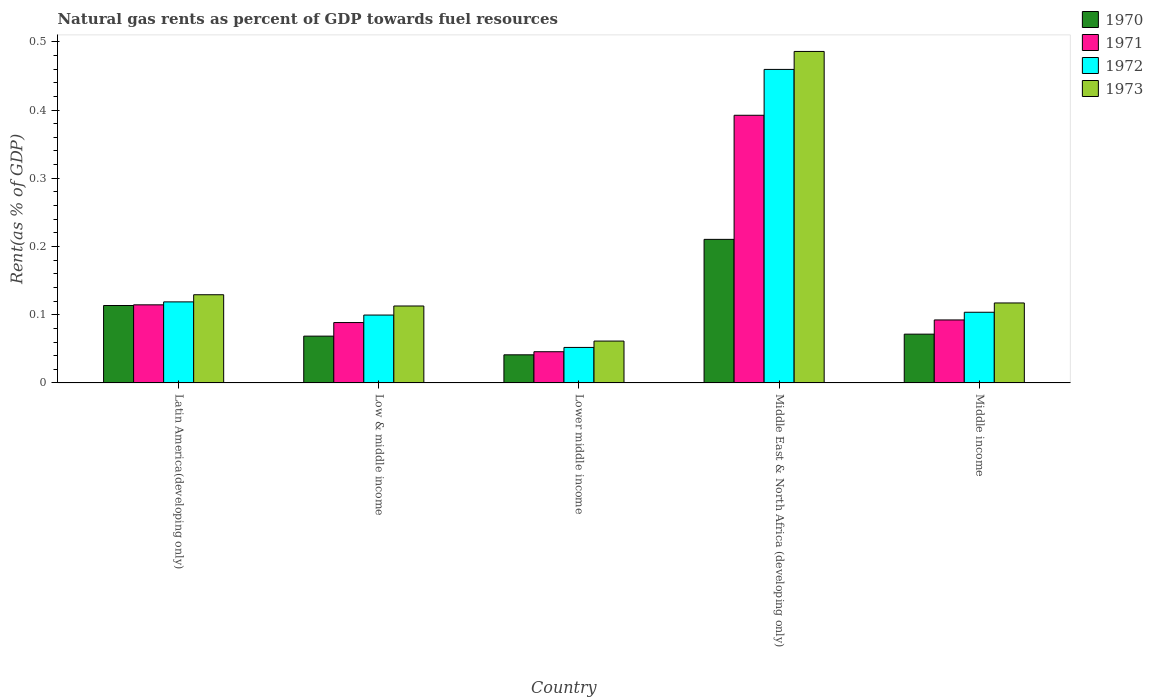Are the number of bars per tick equal to the number of legend labels?
Provide a short and direct response. Yes. How many bars are there on the 2nd tick from the left?
Offer a very short reply. 4. How many bars are there on the 5th tick from the right?
Provide a short and direct response. 4. What is the label of the 5th group of bars from the left?
Provide a short and direct response. Middle income. What is the matural gas rent in 1971 in Low & middle income?
Make the answer very short. 0.09. Across all countries, what is the maximum matural gas rent in 1972?
Offer a very short reply. 0.46. Across all countries, what is the minimum matural gas rent in 1973?
Provide a short and direct response. 0.06. In which country was the matural gas rent in 1972 maximum?
Provide a succinct answer. Middle East & North Africa (developing only). In which country was the matural gas rent in 1970 minimum?
Offer a terse response. Lower middle income. What is the total matural gas rent in 1972 in the graph?
Give a very brief answer. 0.83. What is the difference between the matural gas rent in 1970 in Low & middle income and that in Middle East & North Africa (developing only)?
Make the answer very short. -0.14. What is the difference between the matural gas rent in 1970 in Latin America(developing only) and the matural gas rent in 1973 in Middle income?
Keep it short and to the point. -0. What is the average matural gas rent in 1970 per country?
Provide a succinct answer. 0.1. What is the difference between the matural gas rent of/in 1973 and matural gas rent of/in 1970 in Lower middle income?
Offer a very short reply. 0.02. In how many countries, is the matural gas rent in 1972 greater than 0.1 %?
Provide a succinct answer. 3. What is the ratio of the matural gas rent in 1970 in Low & middle income to that in Middle East & North Africa (developing only)?
Offer a very short reply. 0.33. What is the difference between the highest and the second highest matural gas rent in 1973?
Your response must be concise. 0.37. What is the difference between the highest and the lowest matural gas rent in 1971?
Your response must be concise. 0.35. In how many countries, is the matural gas rent in 1970 greater than the average matural gas rent in 1970 taken over all countries?
Make the answer very short. 2. Is the sum of the matural gas rent in 1973 in Low & middle income and Middle income greater than the maximum matural gas rent in 1972 across all countries?
Offer a terse response. No. Is it the case that in every country, the sum of the matural gas rent in 1970 and matural gas rent in 1972 is greater than the sum of matural gas rent in 1973 and matural gas rent in 1971?
Your response must be concise. No. What does the 4th bar from the left in Latin America(developing only) represents?
Your answer should be compact. 1973. Is it the case that in every country, the sum of the matural gas rent in 1970 and matural gas rent in 1971 is greater than the matural gas rent in 1972?
Provide a succinct answer. Yes. How many bars are there?
Ensure brevity in your answer.  20. Are the values on the major ticks of Y-axis written in scientific E-notation?
Give a very brief answer. No. Does the graph contain any zero values?
Your response must be concise. No. Does the graph contain grids?
Your answer should be very brief. No. Where does the legend appear in the graph?
Offer a terse response. Top right. How are the legend labels stacked?
Offer a very short reply. Vertical. What is the title of the graph?
Ensure brevity in your answer.  Natural gas rents as percent of GDP towards fuel resources. Does "2004" appear as one of the legend labels in the graph?
Provide a short and direct response. No. What is the label or title of the Y-axis?
Provide a succinct answer. Rent(as % of GDP). What is the Rent(as % of GDP) of 1970 in Latin America(developing only)?
Your answer should be very brief. 0.11. What is the Rent(as % of GDP) in 1971 in Latin America(developing only)?
Offer a very short reply. 0.11. What is the Rent(as % of GDP) in 1972 in Latin America(developing only)?
Offer a terse response. 0.12. What is the Rent(as % of GDP) in 1973 in Latin America(developing only)?
Your answer should be very brief. 0.13. What is the Rent(as % of GDP) in 1970 in Low & middle income?
Your answer should be compact. 0.07. What is the Rent(as % of GDP) of 1971 in Low & middle income?
Your answer should be very brief. 0.09. What is the Rent(as % of GDP) of 1972 in Low & middle income?
Offer a very short reply. 0.1. What is the Rent(as % of GDP) in 1973 in Low & middle income?
Provide a short and direct response. 0.11. What is the Rent(as % of GDP) of 1970 in Lower middle income?
Keep it short and to the point. 0.04. What is the Rent(as % of GDP) in 1971 in Lower middle income?
Offer a terse response. 0.05. What is the Rent(as % of GDP) in 1972 in Lower middle income?
Your answer should be compact. 0.05. What is the Rent(as % of GDP) of 1973 in Lower middle income?
Ensure brevity in your answer.  0.06. What is the Rent(as % of GDP) of 1970 in Middle East & North Africa (developing only)?
Make the answer very short. 0.21. What is the Rent(as % of GDP) of 1971 in Middle East & North Africa (developing only)?
Ensure brevity in your answer.  0.39. What is the Rent(as % of GDP) in 1972 in Middle East & North Africa (developing only)?
Your answer should be compact. 0.46. What is the Rent(as % of GDP) in 1973 in Middle East & North Africa (developing only)?
Keep it short and to the point. 0.49. What is the Rent(as % of GDP) in 1970 in Middle income?
Offer a very short reply. 0.07. What is the Rent(as % of GDP) in 1971 in Middle income?
Your response must be concise. 0.09. What is the Rent(as % of GDP) in 1972 in Middle income?
Your response must be concise. 0.1. What is the Rent(as % of GDP) in 1973 in Middle income?
Ensure brevity in your answer.  0.12. Across all countries, what is the maximum Rent(as % of GDP) of 1970?
Make the answer very short. 0.21. Across all countries, what is the maximum Rent(as % of GDP) of 1971?
Provide a short and direct response. 0.39. Across all countries, what is the maximum Rent(as % of GDP) of 1972?
Your answer should be very brief. 0.46. Across all countries, what is the maximum Rent(as % of GDP) in 1973?
Provide a succinct answer. 0.49. Across all countries, what is the minimum Rent(as % of GDP) in 1970?
Provide a succinct answer. 0.04. Across all countries, what is the minimum Rent(as % of GDP) in 1971?
Provide a short and direct response. 0.05. Across all countries, what is the minimum Rent(as % of GDP) in 1972?
Keep it short and to the point. 0.05. Across all countries, what is the minimum Rent(as % of GDP) in 1973?
Give a very brief answer. 0.06. What is the total Rent(as % of GDP) in 1970 in the graph?
Your answer should be very brief. 0.51. What is the total Rent(as % of GDP) of 1971 in the graph?
Ensure brevity in your answer.  0.73. What is the total Rent(as % of GDP) in 1972 in the graph?
Offer a terse response. 0.83. What is the total Rent(as % of GDP) in 1973 in the graph?
Ensure brevity in your answer.  0.91. What is the difference between the Rent(as % of GDP) of 1970 in Latin America(developing only) and that in Low & middle income?
Your answer should be very brief. 0.04. What is the difference between the Rent(as % of GDP) in 1971 in Latin America(developing only) and that in Low & middle income?
Your answer should be very brief. 0.03. What is the difference between the Rent(as % of GDP) of 1972 in Latin America(developing only) and that in Low & middle income?
Keep it short and to the point. 0.02. What is the difference between the Rent(as % of GDP) of 1973 in Latin America(developing only) and that in Low & middle income?
Provide a succinct answer. 0.02. What is the difference between the Rent(as % of GDP) in 1970 in Latin America(developing only) and that in Lower middle income?
Your response must be concise. 0.07. What is the difference between the Rent(as % of GDP) in 1971 in Latin America(developing only) and that in Lower middle income?
Make the answer very short. 0.07. What is the difference between the Rent(as % of GDP) of 1972 in Latin America(developing only) and that in Lower middle income?
Provide a succinct answer. 0.07. What is the difference between the Rent(as % of GDP) in 1973 in Latin America(developing only) and that in Lower middle income?
Give a very brief answer. 0.07. What is the difference between the Rent(as % of GDP) of 1970 in Latin America(developing only) and that in Middle East & North Africa (developing only)?
Your answer should be very brief. -0.1. What is the difference between the Rent(as % of GDP) of 1971 in Latin America(developing only) and that in Middle East & North Africa (developing only)?
Your answer should be compact. -0.28. What is the difference between the Rent(as % of GDP) of 1972 in Latin America(developing only) and that in Middle East & North Africa (developing only)?
Keep it short and to the point. -0.34. What is the difference between the Rent(as % of GDP) in 1973 in Latin America(developing only) and that in Middle East & North Africa (developing only)?
Give a very brief answer. -0.36. What is the difference between the Rent(as % of GDP) of 1970 in Latin America(developing only) and that in Middle income?
Give a very brief answer. 0.04. What is the difference between the Rent(as % of GDP) in 1971 in Latin America(developing only) and that in Middle income?
Give a very brief answer. 0.02. What is the difference between the Rent(as % of GDP) in 1972 in Latin America(developing only) and that in Middle income?
Your response must be concise. 0.02. What is the difference between the Rent(as % of GDP) of 1973 in Latin America(developing only) and that in Middle income?
Offer a very short reply. 0.01. What is the difference between the Rent(as % of GDP) in 1970 in Low & middle income and that in Lower middle income?
Offer a very short reply. 0.03. What is the difference between the Rent(as % of GDP) in 1971 in Low & middle income and that in Lower middle income?
Give a very brief answer. 0.04. What is the difference between the Rent(as % of GDP) of 1972 in Low & middle income and that in Lower middle income?
Provide a succinct answer. 0.05. What is the difference between the Rent(as % of GDP) of 1973 in Low & middle income and that in Lower middle income?
Your answer should be compact. 0.05. What is the difference between the Rent(as % of GDP) of 1970 in Low & middle income and that in Middle East & North Africa (developing only)?
Provide a short and direct response. -0.14. What is the difference between the Rent(as % of GDP) of 1971 in Low & middle income and that in Middle East & North Africa (developing only)?
Ensure brevity in your answer.  -0.3. What is the difference between the Rent(as % of GDP) in 1972 in Low & middle income and that in Middle East & North Africa (developing only)?
Your answer should be compact. -0.36. What is the difference between the Rent(as % of GDP) in 1973 in Low & middle income and that in Middle East & North Africa (developing only)?
Ensure brevity in your answer.  -0.37. What is the difference between the Rent(as % of GDP) in 1970 in Low & middle income and that in Middle income?
Keep it short and to the point. -0. What is the difference between the Rent(as % of GDP) of 1971 in Low & middle income and that in Middle income?
Make the answer very short. -0. What is the difference between the Rent(as % of GDP) in 1972 in Low & middle income and that in Middle income?
Provide a succinct answer. -0. What is the difference between the Rent(as % of GDP) of 1973 in Low & middle income and that in Middle income?
Offer a very short reply. -0. What is the difference between the Rent(as % of GDP) of 1970 in Lower middle income and that in Middle East & North Africa (developing only)?
Ensure brevity in your answer.  -0.17. What is the difference between the Rent(as % of GDP) of 1971 in Lower middle income and that in Middle East & North Africa (developing only)?
Your answer should be very brief. -0.35. What is the difference between the Rent(as % of GDP) of 1972 in Lower middle income and that in Middle East & North Africa (developing only)?
Make the answer very short. -0.41. What is the difference between the Rent(as % of GDP) in 1973 in Lower middle income and that in Middle East & North Africa (developing only)?
Provide a short and direct response. -0.42. What is the difference between the Rent(as % of GDP) of 1970 in Lower middle income and that in Middle income?
Your answer should be very brief. -0.03. What is the difference between the Rent(as % of GDP) of 1971 in Lower middle income and that in Middle income?
Your answer should be very brief. -0.05. What is the difference between the Rent(as % of GDP) in 1972 in Lower middle income and that in Middle income?
Give a very brief answer. -0.05. What is the difference between the Rent(as % of GDP) of 1973 in Lower middle income and that in Middle income?
Offer a very short reply. -0.06. What is the difference between the Rent(as % of GDP) of 1970 in Middle East & North Africa (developing only) and that in Middle income?
Your answer should be compact. 0.14. What is the difference between the Rent(as % of GDP) in 1972 in Middle East & North Africa (developing only) and that in Middle income?
Keep it short and to the point. 0.36. What is the difference between the Rent(as % of GDP) of 1973 in Middle East & North Africa (developing only) and that in Middle income?
Keep it short and to the point. 0.37. What is the difference between the Rent(as % of GDP) in 1970 in Latin America(developing only) and the Rent(as % of GDP) in 1971 in Low & middle income?
Provide a succinct answer. 0.03. What is the difference between the Rent(as % of GDP) of 1970 in Latin America(developing only) and the Rent(as % of GDP) of 1972 in Low & middle income?
Your response must be concise. 0.01. What is the difference between the Rent(as % of GDP) of 1970 in Latin America(developing only) and the Rent(as % of GDP) of 1973 in Low & middle income?
Give a very brief answer. 0. What is the difference between the Rent(as % of GDP) in 1971 in Latin America(developing only) and the Rent(as % of GDP) in 1972 in Low & middle income?
Give a very brief answer. 0.01. What is the difference between the Rent(as % of GDP) in 1971 in Latin America(developing only) and the Rent(as % of GDP) in 1973 in Low & middle income?
Keep it short and to the point. 0. What is the difference between the Rent(as % of GDP) in 1972 in Latin America(developing only) and the Rent(as % of GDP) in 1973 in Low & middle income?
Your answer should be compact. 0.01. What is the difference between the Rent(as % of GDP) in 1970 in Latin America(developing only) and the Rent(as % of GDP) in 1971 in Lower middle income?
Give a very brief answer. 0.07. What is the difference between the Rent(as % of GDP) in 1970 in Latin America(developing only) and the Rent(as % of GDP) in 1972 in Lower middle income?
Offer a very short reply. 0.06. What is the difference between the Rent(as % of GDP) in 1970 in Latin America(developing only) and the Rent(as % of GDP) in 1973 in Lower middle income?
Your answer should be very brief. 0.05. What is the difference between the Rent(as % of GDP) in 1971 in Latin America(developing only) and the Rent(as % of GDP) in 1972 in Lower middle income?
Make the answer very short. 0.06. What is the difference between the Rent(as % of GDP) of 1971 in Latin America(developing only) and the Rent(as % of GDP) of 1973 in Lower middle income?
Your response must be concise. 0.05. What is the difference between the Rent(as % of GDP) of 1972 in Latin America(developing only) and the Rent(as % of GDP) of 1973 in Lower middle income?
Provide a short and direct response. 0.06. What is the difference between the Rent(as % of GDP) of 1970 in Latin America(developing only) and the Rent(as % of GDP) of 1971 in Middle East & North Africa (developing only)?
Your answer should be compact. -0.28. What is the difference between the Rent(as % of GDP) in 1970 in Latin America(developing only) and the Rent(as % of GDP) in 1972 in Middle East & North Africa (developing only)?
Keep it short and to the point. -0.35. What is the difference between the Rent(as % of GDP) of 1970 in Latin America(developing only) and the Rent(as % of GDP) of 1973 in Middle East & North Africa (developing only)?
Provide a succinct answer. -0.37. What is the difference between the Rent(as % of GDP) in 1971 in Latin America(developing only) and the Rent(as % of GDP) in 1972 in Middle East & North Africa (developing only)?
Offer a terse response. -0.35. What is the difference between the Rent(as % of GDP) of 1971 in Latin America(developing only) and the Rent(as % of GDP) of 1973 in Middle East & North Africa (developing only)?
Keep it short and to the point. -0.37. What is the difference between the Rent(as % of GDP) of 1972 in Latin America(developing only) and the Rent(as % of GDP) of 1973 in Middle East & North Africa (developing only)?
Provide a succinct answer. -0.37. What is the difference between the Rent(as % of GDP) of 1970 in Latin America(developing only) and the Rent(as % of GDP) of 1971 in Middle income?
Your response must be concise. 0.02. What is the difference between the Rent(as % of GDP) in 1970 in Latin America(developing only) and the Rent(as % of GDP) in 1972 in Middle income?
Your answer should be very brief. 0.01. What is the difference between the Rent(as % of GDP) in 1970 in Latin America(developing only) and the Rent(as % of GDP) in 1973 in Middle income?
Your answer should be compact. -0. What is the difference between the Rent(as % of GDP) of 1971 in Latin America(developing only) and the Rent(as % of GDP) of 1972 in Middle income?
Keep it short and to the point. 0.01. What is the difference between the Rent(as % of GDP) of 1971 in Latin America(developing only) and the Rent(as % of GDP) of 1973 in Middle income?
Ensure brevity in your answer.  -0. What is the difference between the Rent(as % of GDP) of 1972 in Latin America(developing only) and the Rent(as % of GDP) of 1973 in Middle income?
Give a very brief answer. 0. What is the difference between the Rent(as % of GDP) of 1970 in Low & middle income and the Rent(as % of GDP) of 1971 in Lower middle income?
Ensure brevity in your answer.  0.02. What is the difference between the Rent(as % of GDP) of 1970 in Low & middle income and the Rent(as % of GDP) of 1972 in Lower middle income?
Provide a short and direct response. 0.02. What is the difference between the Rent(as % of GDP) of 1970 in Low & middle income and the Rent(as % of GDP) of 1973 in Lower middle income?
Ensure brevity in your answer.  0.01. What is the difference between the Rent(as % of GDP) in 1971 in Low & middle income and the Rent(as % of GDP) in 1972 in Lower middle income?
Your response must be concise. 0.04. What is the difference between the Rent(as % of GDP) of 1971 in Low & middle income and the Rent(as % of GDP) of 1973 in Lower middle income?
Give a very brief answer. 0.03. What is the difference between the Rent(as % of GDP) of 1972 in Low & middle income and the Rent(as % of GDP) of 1973 in Lower middle income?
Make the answer very short. 0.04. What is the difference between the Rent(as % of GDP) of 1970 in Low & middle income and the Rent(as % of GDP) of 1971 in Middle East & North Africa (developing only)?
Offer a terse response. -0.32. What is the difference between the Rent(as % of GDP) in 1970 in Low & middle income and the Rent(as % of GDP) in 1972 in Middle East & North Africa (developing only)?
Your answer should be very brief. -0.39. What is the difference between the Rent(as % of GDP) in 1970 in Low & middle income and the Rent(as % of GDP) in 1973 in Middle East & North Africa (developing only)?
Make the answer very short. -0.42. What is the difference between the Rent(as % of GDP) of 1971 in Low & middle income and the Rent(as % of GDP) of 1972 in Middle East & North Africa (developing only)?
Ensure brevity in your answer.  -0.37. What is the difference between the Rent(as % of GDP) in 1971 in Low & middle income and the Rent(as % of GDP) in 1973 in Middle East & North Africa (developing only)?
Offer a very short reply. -0.4. What is the difference between the Rent(as % of GDP) in 1972 in Low & middle income and the Rent(as % of GDP) in 1973 in Middle East & North Africa (developing only)?
Keep it short and to the point. -0.39. What is the difference between the Rent(as % of GDP) in 1970 in Low & middle income and the Rent(as % of GDP) in 1971 in Middle income?
Keep it short and to the point. -0.02. What is the difference between the Rent(as % of GDP) in 1970 in Low & middle income and the Rent(as % of GDP) in 1972 in Middle income?
Provide a short and direct response. -0.04. What is the difference between the Rent(as % of GDP) in 1970 in Low & middle income and the Rent(as % of GDP) in 1973 in Middle income?
Your response must be concise. -0.05. What is the difference between the Rent(as % of GDP) of 1971 in Low & middle income and the Rent(as % of GDP) of 1972 in Middle income?
Provide a short and direct response. -0.02. What is the difference between the Rent(as % of GDP) in 1971 in Low & middle income and the Rent(as % of GDP) in 1973 in Middle income?
Your response must be concise. -0.03. What is the difference between the Rent(as % of GDP) of 1972 in Low & middle income and the Rent(as % of GDP) of 1973 in Middle income?
Your response must be concise. -0.02. What is the difference between the Rent(as % of GDP) in 1970 in Lower middle income and the Rent(as % of GDP) in 1971 in Middle East & North Africa (developing only)?
Give a very brief answer. -0.35. What is the difference between the Rent(as % of GDP) in 1970 in Lower middle income and the Rent(as % of GDP) in 1972 in Middle East & North Africa (developing only)?
Make the answer very short. -0.42. What is the difference between the Rent(as % of GDP) in 1970 in Lower middle income and the Rent(as % of GDP) in 1973 in Middle East & North Africa (developing only)?
Your response must be concise. -0.44. What is the difference between the Rent(as % of GDP) in 1971 in Lower middle income and the Rent(as % of GDP) in 1972 in Middle East & North Africa (developing only)?
Your response must be concise. -0.41. What is the difference between the Rent(as % of GDP) in 1971 in Lower middle income and the Rent(as % of GDP) in 1973 in Middle East & North Africa (developing only)?
Make the answer very short. -0.44. What is the difference between the Rent(as % of GDP) of 1972 in Lower middle income and the Rent(as % of GDP) of 1973 in Middle East & North Africa (developing only)?
Ensure brevity in your answer.  -0.43. What is the difference between the Rent(as % of GDP) of 1970 in Lower middle income and the Rent(as % of GDP) of 1971 in Middle income?
Make the answer very short. -0.05. What is the difference between the Rent(as % of GDP) of 1970 in Lower middle income and the Rent(as % of GDP) of 1972 in Middle income?
Offer a very short reply. -0.06. What is the difference between the Rent(as % of GDP) of 1970 in Lower middle income and the Rent(as % of GDP) of 1973 in Middle income?
Provide a short and direct response. -0.08. What is the difference between the Rent(as % of GDP) in 1971 in Lower middle income and the Rent(as % of GDP) in 1972 in Middle income?
Offer a terse response. -0.06. What is the difference between the Rent(as % of GDP) of 1971 in Lower middle income and the Rent(as % of GDP) of 1973 in Middle income?
Offer a very short reply. -0.07. What is the difference between the Rent(as % of GDP) of 1972 in Lower middle income and the Rent(as % of GDP) of 1973 in Middle income?
Provide a short and direct response. -0.07. What is the difference between the Rent(as % of GDP) of 1970 in Middle East & North Africa (developing only) and the Rent(as % of GDP) of 1971 in Middle income?
Your answer should be very brief. 0.12. What is the difference between the Rent(as % of GDP) in 1970 in Middle East & North Africa (developing only) and the Rent(as % of GDP) in 1972 in Middle income?
Keep it short and to the point. 0.11. What is the difference between the Rent(as % of GDP) of 1970 in Middle East & North Africa (developing only) and the Rent(as % of GDP) of 1973 in Middle income?
Ensure brevity in your answer.  0.09. What is the difference between the Rent(as % of GDP) of 1971 in Middle East & North Africa (developing only) and the Rent(as % of GDP) of 1972 in Middle income?
Make the answer very short. 0.29. What is the difference between the Rent(as % of GDP) in 1971 in Middle East & North Africa (developing only) and the Rent(as % of GDP) in 1973 in Middle income?
Offer a terse response. 0.28. What is the difference between the Rent(as % of GDP) in 1972 in Middle East & North Africa (developing only) and the Rent(as % of GDP) in 1973 in Middle income?
Make the answer very short. 0.34. What is the average Rent(as % of GDP) of 1970 per country?
Keep it short and to the point. 0.1. What is the average Rent(as % of GDP) of 1971 per country?
Offer a very short reply. 0.15. What is the average Rent(as % of GDP) in 1972 per country?
Offer a terse response. 0.17. What is the average Rent(as % of GDP) of 1973 per country?
Provide a succinct answer. 0.18. What is the difference between the Rent(as % of GDP) in 1970 and Rent(as % of GDP) in 1971 in Latin America(developing only)?
Make the answer very short. -0. What is the difference between the Rent(as % of GDP) in 1970 and Rent(as % of GDP) in 1972 in Latin America(developing only)?
Your response must be concise. -0.01. What is the difference between the Rent(as % of GDP) in 1970 and Rent(as % of GDP) in 1973 in Latin America(developing only)?
Your response must be concise. -0.02. What is the difference between the Rent(as % of GDP) of 1971 and Rent(as % of GDP) of 1972 in Latin America(developing only)?
Keep it short and to the point. -0. What is the difference between the Rent(as % of GDP) of 1971 and Rent(as % of GDP) of 1973 in Latin America(developing only)?
Offer a very short reply. -0.01. What is the difference between the Rent(as % of GDP) in 1972 and Rent(as % of GDP) in 1973 in Latin America(developing only)?
Give a very brief answer. -0.01. What is the difference between the Rent(as % of GDP) in 1970 and Rent(as % of GDP) in 1971 in Low & middle income?
Ensure brevity in your answer.  -0.02. What is the difference between the Rent(as % of GDP) of 1970 and Rent(as % of GDP) of 1972 in Low & middle income?
Provide a succinct answer. -0.03. What is the difference between the Rent(as % of GDP) of 1970 and Rent(as % of GDP) of 1973 in Low & middle income?
Ensure brevity in your answer.  -0.04. What is the difference between the Rent(as % of GDP) in 1971 and Rent(as % of GDP) in 1972 in Low & middle income?
Your answer should be very brief. -0.01. What is the difference between the Rent(as % of GDP) of 1971 and Rent(as % of GDP) of 1973 in Low & middle income?
Your answer should be very brief. -0.02. What is the difference between the Rent(as % of GDP) in 1972 and Rent(as % of GDP) in 1973 in Low & middle income?
Keep it short and to the point. -0.01. What is the difference between the Rent(as % of GDP) in 1970 and Rent(as % of GDP) in 1971 in Lower middle income?
Provide a short and direct response. -0. What is the difference between the Rent(as % of GDP) in 1970 and Rent(as % of GDP) in 1972 in Lower middle income?
Keep it short and to the point. -0.01. What is the difference between the Rent(as % of GDP) of 1970 and Rent(as % of GDP) of 1973 in Lower middle income?
Your answer should be compact. -0.02. What is the difference between the Rent(as % of GDP) in 1971 and Rent(as % of GDP) in 1972 in Lower middle income?
Offer a terse response. -0.01. What is the difference between the Rent(as % of GDP) of 1971 and Rent(as % of GDP) of 1973 in Lower middle income?
Your answer should be compact. -0.02. What is the difference between the Rent(as % of GDP) in 1972 and Rent(as % of GDP) in 1973 in Lower middle income?
Offer a very short reply. -0.01. What is the difference between the Rent(as % of GDP) in 1970 and Rent(as % of GDP) in 1971 in Middle East & North Africa (developing only)?
Your answer should be very brief. -0.18. What is the difference between the Rent(as % of GDP) of 1970 and Rent(as % of GDP) of 1972 in Middle East & North Africa (developing only)?
Give a very brief answer. -0.25. What is the difference between the Rent(as % of GDP) in 1970 and Rent(as % of GDP) in 1973 in Middle East & North Africa (developing only)?
Your response must be concise. -0.28. What is the difference between the Rent(as % of GDP) in 1971 and Rent(as % of GDP) in 1972 in Middle East & North Africa (developing only)?
Provide a succinct answer. -0.07. What is the difference between the Rent(as % of GDP) in 1971 and Rent(as % of GDP) in 1973 in Middle East & North Africa (developing only)?
Your response must be concise. -0.09. What is the difference between the Rent(as % of GDP) in 1972 and Rent(as % of GDP) in 1973 in Middle East & North Africa (developing only)?
Offer a very short reply. -0.03. What is the difference between the Rent(as % of GDP) of 1970 and Rent(as % of GDP) of 1971 in Middle income?
Offer a very short reply. -0.02. What is the difference between the Rent(as % of GDP) in 1970 and Rent(as % of GDP) in 1972 in Middle income?
Give a very brief answer. -0.03. What is the difference between the Rent(as % of GDP) in 1970 and Rent(as % of GDP) in 1973 in Middle income?
Make the answer very short. -0.05. What is the difference between the Rent(as % of GDP) in 1971 and Rent(as % of GDP) in 1972 in Middle income?
Offer a terse response. -0.01. What is the difference between the Rent(as % of GDP) of 1971 and Rent(as % of GDP) of 1973 in Middle income?
Make the answer very short. -0.02. What is the difference between the Rent(as % of GDP) of 1972 and Rent(as % of GDP) of 1973 in Middle income?
Provide a short and direct response. -0.01. What is the ratio of the Rent(as % of GDP) in 1970 in Latin America(developing only) to that in Low & middle income?
Keep it short and to the point. 1.65. What is the ratio of the Rent(as % of GDP) in 1971 in Latin America(developing only) to that in Low & middle income?
Provide a short and direct response. 1.29. What is the ratio of the Rent(as % of GDP) of 1972 in Latin America(developing only) to that in Low & middle income?
Provide a short and direct response. 1.19. What is the ratio of the Rent(as % of GDP) of 1973 in Latin America(developing only) to that in Low & middle income?
Provide a short and direct response. 1.15. What is the ratio of the Rent(as % of GDP) of 1970 in Latin America(developing only) to that in Lower middle income?
Make the answer very short. 2.75. What is the ratio of the Rent(as % of GDP) of 1971 in Latin America(developing only) to that in Lower middle income?
Ensure brevity in your answer.  2.5. What is the ratio of the Rent(as % of GDP) in 1972 in Latin America(developing only) to that in Lower middle income?
Keep it short and to the point. 2.28. What is the ratio of the Rent(as % of GDP) of 1973 in Latin America(developing only) to that in Lower middle income?
Offer a very short reply. 2.11. What is the ratio of the Rent(as % of GDP) of 1970 in Latin America(developing only) to that in Middle East & North Africa (developing only)?
Keep it short and to the point. 0.54. What is the ratio of the Rent(as % of GDP) of 1971 in Latin America(developing only) to that in Middle East & North Africa (developing only)?
Provide a succinct answer. 0.29. What is the ratio of the Rent(as % of GDP) in 1972 in Latin America(developing only) to that in Middle East & North Africa (developing only)?
Provide a short and direct response. 0.26. What is the ratio of the Rent(as % of GDP) of 1973 in Latin America(developing only) to that in Middle East & North Africa (developing only)?
Provide a short and direct response. 0.27. What is the ratio of the Rent(as % of GDP) in 1970 in Latin America(developing only) to that in Middle income?
Provide a succinct answer. 1.59. What is the ratio of the Rent(as % of GDP) in 1971 in Latin America(developing only) to that in Middle income?
Provide a short and direct response. 1.24. What is the ratio of the Rent(as % of GDP) in 1972 in Latin America(developing only) to that in Middle income?
Offer a very short reply. 1.15. What is the ratio of the Rent(as % of GDP) of 1973 in Latin America(developing only) to that in Middle income?
Ensure brevity in your answer.  1.1. What is the ratio of the Rent(as % of GDP) in 1970 in Low & middle income to that in Lower middle income?
Provide a succinct answer. 1.66. What is the ratio of the Rent(as % of GDP) of 1971 in Low & middle income to that in Lower middle income?
Offer a terse response. 1.93. What is the ratio of the Rent(as % of GDP) in 1972 in Low & middle income to that in Lower middle income?
Offer a terse response. 1.91. What is the ratio of the Rent(as % of GDP) in 1973 in Low & middle income to that in Lower middle income?
Offer a terse response. 1.84. What is the ratio of the Rent(as % of GDP) of 1970 in Low & middle income to that in Middle East & North Africa (developing only)?
Ensure brevity in your answer.  0.33. What is the ratio of the Rent(as % of GDP) of 1971 in Low & middle income to that in Middle East & North Africa (developing only)?
Your response must be concise. 0.23. What is the ratio of the Rent(as % of GDP) in 1972 in Low & middle income to that in Middle East & North Africa (developing only)?
Offer a very short reply. 0.22. What is the ratio of the Rent(as % of GDP) in 1973 in Low & middle income to that in Middle East & North Africa (developing only)?
Offer a very short reply. 0.23. What is the ratio of the Rent(as % of GDP) in 1970 in Low & middle income to that in Middle income?
Offer a very short reply. 0.96. What is the ratio of the Rent(as % of GDP) of 1971 in Low & middle income to that in Middle income?
Ensure brevity in your answer.  0.96. What is the ratio of the Rent(as % of GDP) of 1972 in Low & middle income to that in Middle income?
Your answer should be compact. 0.96. What is the ratio of the Rent(as % of GDP) of 1973 in Low & middle income to that in Middle income?
Offer a very short reply. 0.96. What is the ratio of the Rent(as % of GDP) of 1970 in Lower middle income to that in Middle East & North Africa (developing only)?
Offer a terse response. 0.2. What is the ratio of the Rent(as % of GDP) in 1971 in Lower middle income to that in Middle East & North Africa (developing only)?
Ensure brevity in your answer.  0.12. What is the ratio of the Rent(as % of GDP) in 1972 in Lower middle income to that in Middle East & North Africa (developing only)?
Keep it short and to the point. 0.11. What is the ratio of the Rent(as % of GDP) of 1973 in Lower middle income to that in Middle East & North Africa (developing only)?
Your response must be concise. 0.13. What is the ratio of the Rent(as % of GDP) in 1970 in Lower middle income to that in Middle income?
Your response must be concise. 0.58. What is the ratio of the Rent(as % of GDP) of 1971 in Lower middle income to that in Middle income?
Provide a succinct answer. 0.5. What is the ratio of the Rent(as % of GDP) in 1972 in Lower middle income to that in Middle income?
Give a very brief answer. 0.5. What is the ratio of the Rent(as % of GDP) of 1973 in Lower middle income to that in Middle income?
Give a very brief answer. 0.52. What is the ratio of the Rent(as % of GDP) of 1970 in Middle East & North Africa (developing only) to that in Middle income?
Offer a terse response. 2.94. What is the ratio of the Rent(as % of GDP) in 1971 in Middle East & North Africa (developing only) to that in Middle income?
Provide a short and direct response. 4.25. What is the ratio of the Rent(as % of GDP) of 1972 in Middle East & North Africa (developing only) to that in Middle income?
Offer a very short reply. 4.44. What is the ratio of the Rent(as % of GDP) of 1973 in Middle East & North Africa (developing only) to that in Middle income?
Provide a short and direct response. 4.14. What is the difference between the highest and the second highest Rent(as % of GDP) of 1970?
Offer a very short reply. 0.1. What is the difference between the highest and the second highest Rent(as % of GDP) of 1971?
Your response must be concise. 0.28. What is the difference between the highest and the second highest Rent(as % of GDP) in 1972?
Keep it short and to the point. 0.34. What is the difference between the highest and the second highest Rent(as % of GDP) of 1973?
Provide a succinct answer. 0.36. What is the difference between the highest and the lowest Rent(as % of GDP) of 1970?
Your answer should be compact. 0.17. What is the difference between the highest and the lowest Rent(as % of GDP) in 1971?
Offer a very short reply. 0.35. What is the difference between the highest and the lowest Rent(as % of GDP) of 1972?
Provide a short and direct response. 0.41. What is the difference between the highest and the lowest Rent(as % of GDP) in 1973?
Provide a short and direct response. 0.42. 